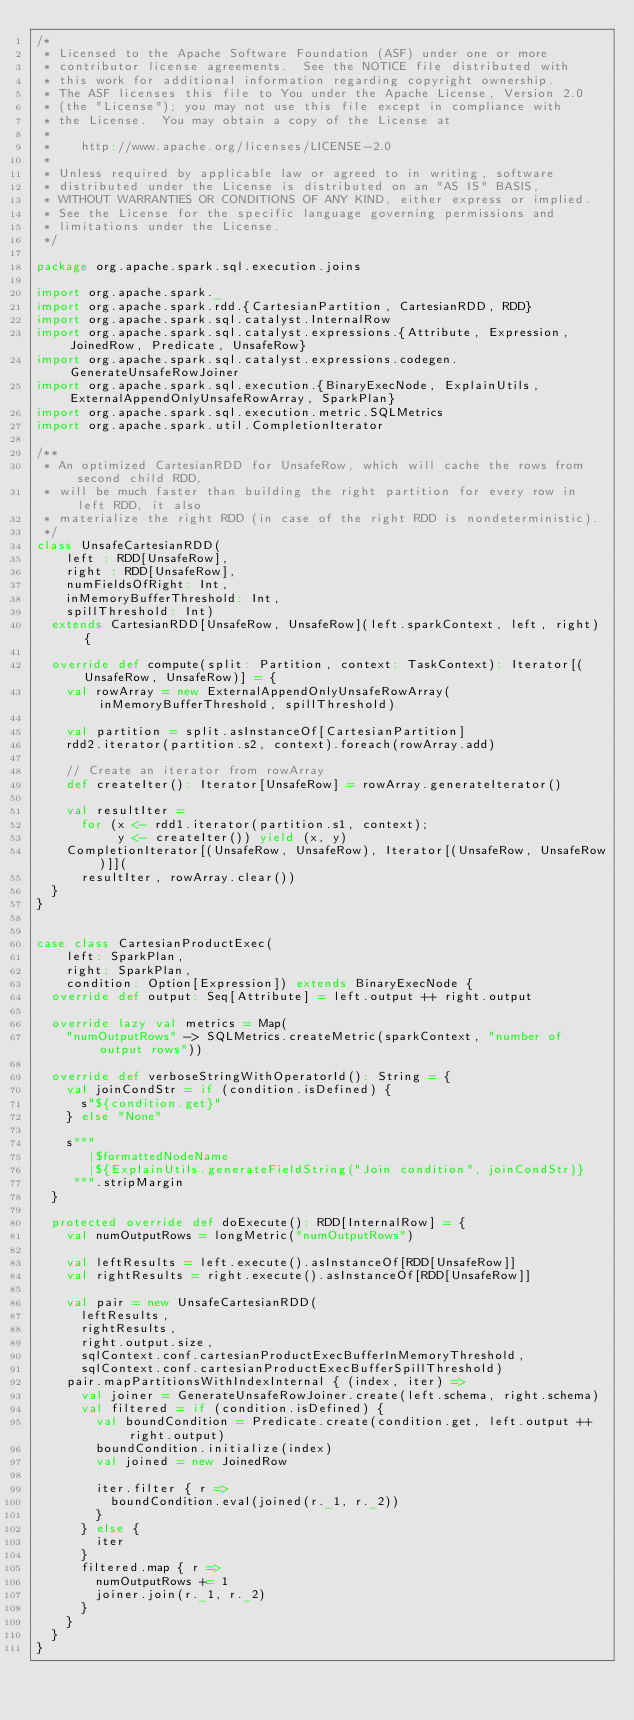<code> <loc_0><loc_0><loc_500><loc_500><_Scala_>/*
 * Licensed to the Apache Software Foundation (ASF) under one or more
 * contributor license agreements.  See the NOTICE file distributed with
 * this work for additional information regarding copyright ownership.
 * The ASF licenses this file to You under the Apache License, Version 2.0
 * (the "License"); you may not use this file except in compliance with
 * the License.  You may obtain a copy of the License at
 *
 *    http://www.apache.org/licenses/LICENSE-2.0
 *
 * Unless required by applicable law or agreed to in writing, software
 * distributed under the License is distributed on an "AS IS" BASIS,
 * WITHOUT WARRANTIES OR CONDITIONS OF ANY KIND, either express or implied.
 * See the License for the specific language governing permissions and
 * limitations under the License.
 */

package org.apache.spark.sql.execution.joins

import org.apache.spark._
import org.apache.spark.rdd.{CartesianPartition, CartesianRDD, RDD}
import org.apache.spark.sql.catalyst.InternalRow
import org.apache.spark.sql.catalyst.expressions.{Attribute, Expression, JoinedRow, Predicate, UnsafeRow}
import org.apache.spark.sql.catalyst.expressions.codegen.GenerateUnsafeRowJoiner
import org.apache.spark.sql.execution.{BinaryExecNode, ExplainUtils, ExternalAppendOnlyUnsafeRowArray, SparkPlan}
import org.apache.spark.sql.execution.metric.SQLMetrics
import org.apache.spark.util.CompletionIterator

/**
 * An optimized CartesianRDD for UnsafeRow, which will cache the rows from second child RDD,
 * will be much faster than building the right partition for every row in left RDD, it also
 * materialize the right RDD (in case of the right RDD is nondeterministic).
 */
class UnsafeCartesianRDD(
    left : RDD[UnsafeRow],
    right : RDD[UnsafeRow],
    numFieldsOfRight: Int,
    inMemoryBufferThreshold: Int,
    spillThreshold: Int)
  extends CartesianRDD[UnsafeRow, UnsafeRow](left.sparkContext, left, right) {

  override def compute(split: Partition, context: TaskContext): Iterator[(UnsafeRow, UnsafeRow)] = {
    val rowArray = new ExternalAppendOnlyUnsafeRowArray(inMemoryBufferThreshold, spillThreshold)

    val partition = split.asInstanceOf[CartesianPartition]
    rdd2.iterator(partition.s2, context).foreach(rowArray.add)

    // Create an iterator from rowArray
    def createIter(): Iterator[UnsafeRow] = rowArray.generateIterator()

    val resultIter =
      for (x <- rdd1.iterator(partition.s1, context);
           y <- createIter()) yield (x, y)
    CompletionIterator[(UnsafeRow, UnsafeRow), Iterator[(UnsafeRow, UnsafeRow)]](
      resultIter, rowArray.clear())
  }
}


case class CartesianProductExec(
    left: SparkPlan,
    right: SparkPlan,
    condition: Option[Expression]) extends BinaryExecNode {
  override def output: Seq[Attribute] = left.output ++ right.output

  override lazy val metrics = Map(
    "numOutputRows" -> SQLMetrics.createMetric(sparkContext, "number of output rows"))

  override def verboseStringWithOperatorId(): String = {
    val joinCondStr = if (condition.isDefined) {
      s"${condition.get}"
    } else "None"

    s"""
       |$formattedNodeName
       |${ExplainUtils.generateFieldString("Join condition", joinCondStr)}
     """.stripMargin
  }

  protected override def doExecute(): RDD[InternalRow] = {
    val numOutputRows = longMetric("numOutputRows")

    val leftResults = left.execute().asInstanceOf[RDD[UnsafeRow]]
    val rightResults = right.execute().asInstanceOf[RDD[UnsafeRow]]

    val pair = new UnsafeCartesianRDD(
      leftResults,
      rightResults,
      right.output.size,
      sqlContext.conf.cartesianProductExecBufferInMemoryThreshold,
      sqlContext.conf.cartesianProductExecBufferSpillThreshold)
    pair.mapPartitionsWithIndexInternal { (index, iter) =>
      val joiner = GenerateUnsafeRowJoiner.create(left.schema, right.schema)
      val filtered = if (condition.isDefined) {
        val boundCondition = Predicate.create(condition.get, left.output ++ right.output)
        boundCondition.initialize(index)
        val joined = new JoinedRow

        iter.filter { r =>
          boundCondition.eval(joined(r._1, r._2))
        }
      } else {
        iter
      }
      filtered.map { r =>
        numOutputRows += 1
        joiner.join(r._1, r._2)
      }
    }
  }
}
</code> 